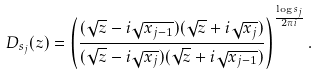Convert formula to latex. <formula><loc_0><loc_0><loc_500><loc_500>D _ { s _ { j } } ( z ) = \left ( \frac { ( \sqrt { z } - i \sqrt { x _ { j - 1 } } ) ( \sqrt { z } + i \sqrt { x _ { j } } ) } { ( \sqrt { z } - i \sqrt { x _ { j } } ) ( \sqrt { z } + i \sqrt { x _ { j - 1 } } ) } \right ) ^ { \frac { \log s _ { j } } { 2 \pi i } } .</formula> 